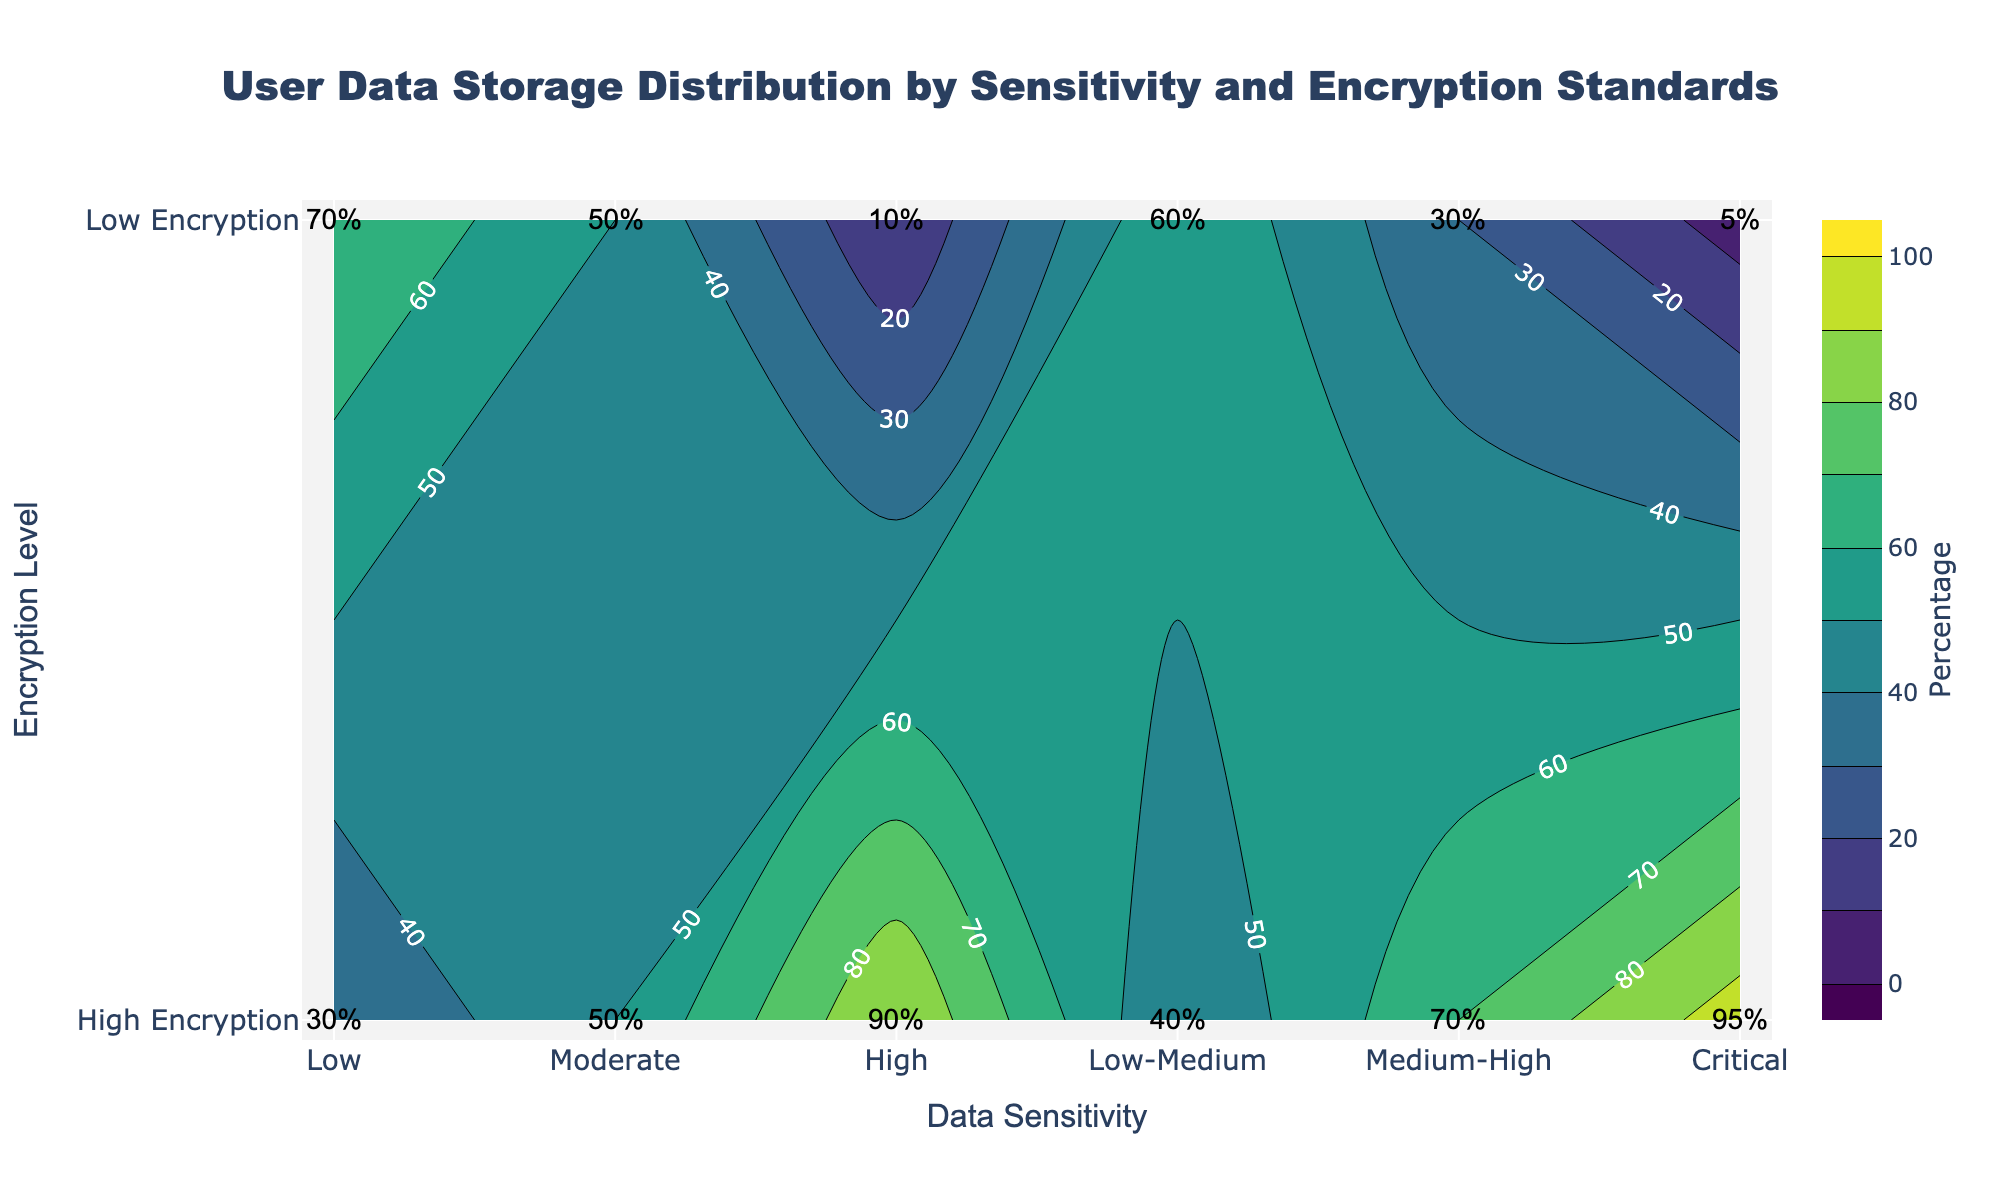what is the title of the plot? Look at the top of the plot where the title is located. It should clearly describe what the plot is about.
Answer: User Data Storage Distribution by Sensitivity and Encryption Standards How many sensitivity levels are shown in the plot? Count the distinct sensitivity levels on the x-axis. They generally represent different categories based on data sensitivity.
Answer: 6 What is the percentage of "High Sensitivity" data that uses high encryption? Identify the "High Sensitivity" label on the x-axis, move up to intersect with the "High Encryption" y-axis value, and look at the annotation.
Answer: 90% Among Critical, High, and Moderate sensitivity levels, which one has the highest percentage of low encryption usage? Compare the percentages of low encryption usage for Critical, High, and Moderate sensitivities, and find the highest one.
Answer: Moderate What's the average percentage of data using high encryption for Low, Low-Medium, and Medium-High sensitivities? Find the high encryption percentages for Low, Low-Medium, and Medium-High: (30, 40, 70), then sum these values and divide by 3.
Answer: 46.67% Which sensitivity level shows the greatest difference between high and low encryption percentages? For each sensitivity level, find the difference between the high encryption and low encryption percentages, and identify the largest difference. Calculation: (95-5) = 90 for Critical, which is the greatest difference.
Answer: Critical How does the color change from low to high encryption percentages? Observe the color gradient used in the plot. Identify the transition in the color scale from low to high percentages.
Answer: From dark to light (usually a shift from dark blue to yellow or green in Viridis) Which sensitivity level has an equal distribution of high and low encryption? Look for the sensitivity level where the percentages for high and low encryption are equal. For example, spot the annotations showing the same values.
Answer: Moderate What's the total combined percentage of high encryption data for Low and Critical sensitivities? Sum the high encryption percentages for Low (30%) and Critical (95%).
Answer: 125% For the "Medium-High" sensitivity level, what's the ratio of high to low encryption percentages? Find the high and low encryption percentages for "Medium-High" (70% and 30%, respectively) and form a ratio.
Answer: 7:3 